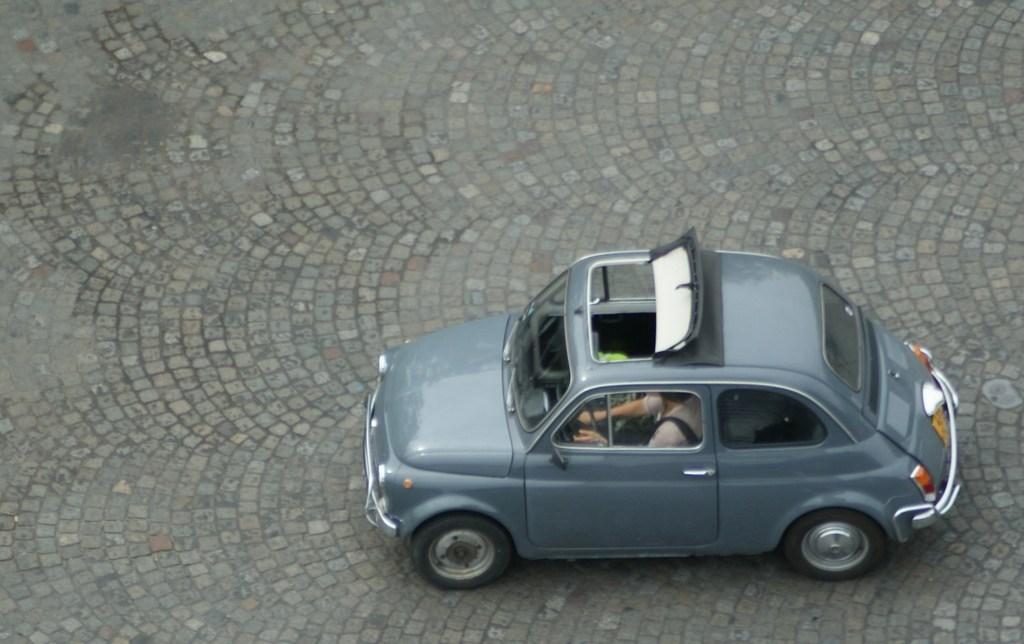Can you describe this image briefly? In this image we can see a car and a person is sitting in a car. 